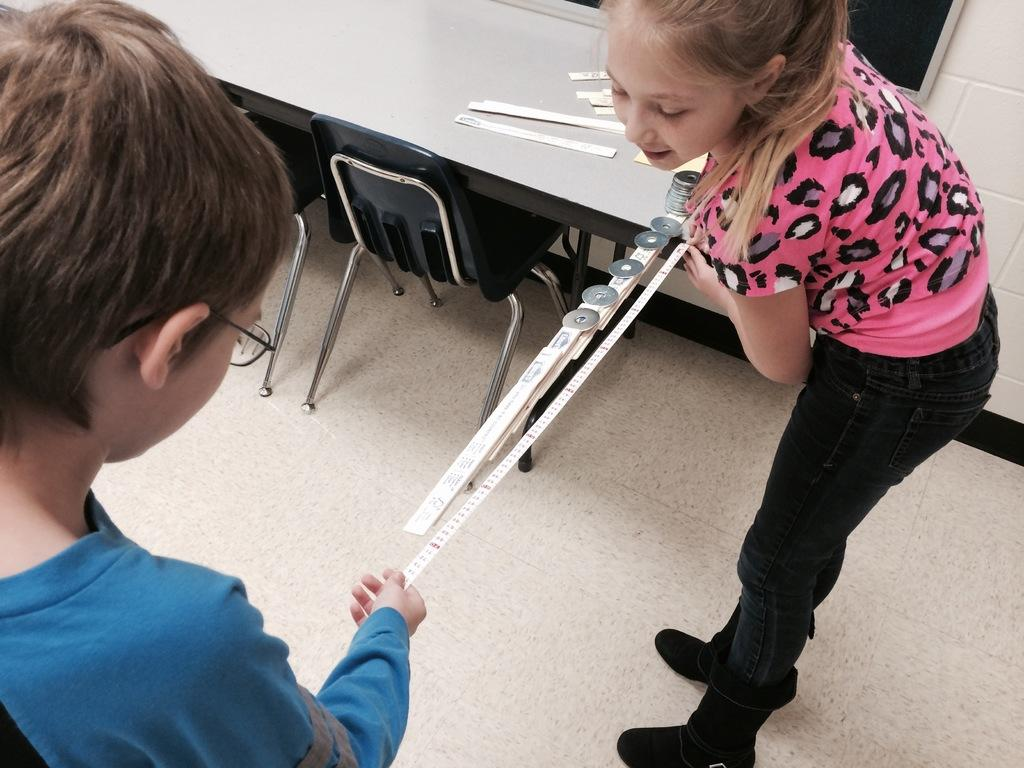Who are the people in the image? There is a boy and a girl in the image. What are they doing in the image? They are standing on a scale. What other furniture can be seen in the image? Chairs and a table are visible at the top of the image. What is visible in the background of the image? There is a wall in the background of the image. What type of nut is being used to hold the table and chairs together in the image? There is no nut visible in the image, and the table and chairs are not being held together by any nuts. 